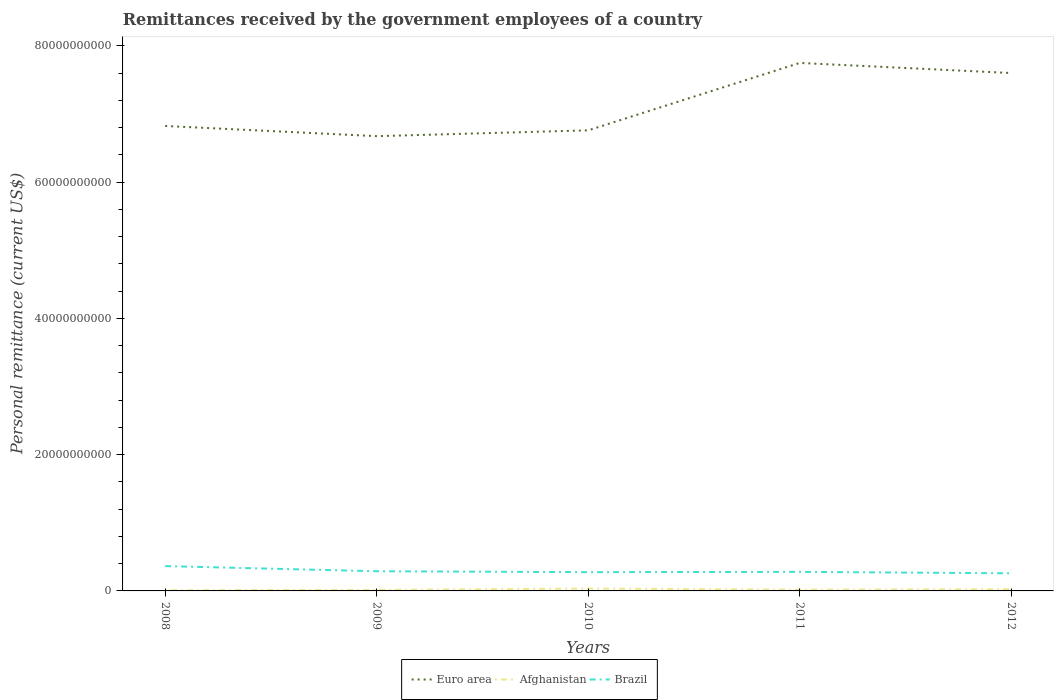How many different coloured lines are there?
Give a very brief answer. 3. Does the line corresponding to Brazil intersect with the line corresponding to Afghanistan?
Provide a short and direct response. No. Is the number of lines equal to the number of legend labels?
Provide a short and direct response. Yes. Across all years, what is the maximum remittances received by the government employees in Euro area?
Your response must be concise. 6.68e+1. In which year was the remittances received by the government employees in Brazil maximum?
Give a very brief answer. 2012. What is the total remittances received by the government employees in Brazil in the graph?
Your answer should be compact. 8.88e+08. What is the difference between the highest and the second highest remittances received by the government employees in Brazil?
Offer a terse response. 1.06e+09. What is the difference between two consecutive major ticks on the Y-axis?
Give a very brief answer. 2.00e+1. Does the graph contain any zero values?
Offer a very short reply. No. Does the graph contain grids?
Your answer should be very brief. No. How many legend labels are there?
Provide a short and direct response. 3. How are the legend labels stacked?
Your answer should be compact. Horizontal. What is the title of the graph?
Offer a very short reply. Remittances received by the government employees of a country. What is the label or title of the Y-axis?
Offer a very short reply. Personal remittance (current US$). What is the Personal remittance (current US$) of Euro area in 2008?
Give a very brief answer. 6.83e+1. What is the Personal remittance (current US$) of Afghanistan in 2008?
Your response must be concise. 1.06e+08. What is the Personal remittance (current US$) in Brazil in 2008?
Keep it short and to the point. 3.64e+09. What is the Personal remittance (current US$) in Euro area in 2009?
Your answer should be very brief. 6.68e+1. What is the Personal remittance (current US$) of Afghanistan in 2009?
Make the answer very short. 1.52e+08. What is the Personal remittance (current US$) in Brazil in 2009?
Offer a terse response. 2.89e+09. What is the Personal remittance (current US$) in Euro area in 2010?
Make the answer very short. 6.76e+1. What is the Personal remittance (current US$) of Afghanistan in 2010?
Make the answer very short. 3.42e+08. What is the Personal remittance (current US$) of Brazil in 2010?
Ensure brevity in your answer.  2.75e+09. What is the Personal remittance (current US$) in Euro area in 2011?
Give a very brief answer. 7.75e+1. What is the Personal remittance (current US$) in Afghanistan in 2011?
Offer a very short reply. 1.85e+08. What is the Personal remittance (current US$) in Brazil in 2011?
Ensure brevity in your answer.  2.80e+09. What is the Personal remittance (current US$) in Euro area in 2012?
Offer a terse response. 7.60e+1. What is the Personal remittance (current US$) of Afghanistan in 2012?
Your response must be concise. 2.52e+08. What is the Personal remittance (current US$) in Brazil in 2012?
Make the answer very short. 2.58e+09. Across all years, what is the maximum Personal remittance (current US$) of Euro area?
Provide a succinct answer. 7.75e+1. Across all years, what is the maximum Personal remittance (current US$) of Afghanistan?
Provide a short and direct response. 3.42e+08. Across all years, what is the maximum Personal remittance (current US$) of Brazil?
Offer a terse response. 3.64e+09. Across all years, what is the minimum Personal remittance (current US$) in Euro area?
Ensure brevity in your answer.  6.68e+1. Across all years, what is the minimum Personal remittance (current US$) of Afghanistan?
Give a very brief answer. 1.06e+08. Across all years, what is the minimum Personal remittance (current US$) of Brazil?
Keep it short and to the point. 2.58e+09. What is the total Personal remittance (current US$) in Euro area in the graph?
Your answer should be very brief. 3.56e+11. What is the total Personal remittance (current US$) in Afghanistan in the graph?
Keep it short and to the point. 1.04e+09. What is the total Personal remittance (current US$) in Brazil in the graph?
Offer a terse response. 1.47e+1. What is the difference between the Personal remittance (current US$) in Euro area in 2008 and that in 2009?
Make the answer very short. 1.50e+09. What is the difference between the Personal remittance (current US$) in Afghanistan in 2008 and that in 2009?
Ensure brevity in your answer.  -4.65e+07. What is the difference between the Personal remittance (current US$) of Brazil in 2008 and that in 2009?
Give a very brief answer. 7.53e+08. What is the difference between the Personal remittance (current US$) of Euro area in 2008 and that in 2010?
Keep it short and to the point. 6.42e+08. What is the difference between the Personal remittance (current US$) in Afghanistan in 2008 and that in 2010?
Offer a terse response. -2.36e+08. What is the difference between the Personal remittance (current US$) in Brazil in 2008 and that in 2010?
Your answer should be compact. 8.88e+08. What is the difference between the Personal remittance (current US$) of Euro area in 2008 and that in 2011?
Give a very brief answer. -9.25e+09. What is the difference between the Personal remittance (current US$) of Afghanistan in 2008 and that in 2011?
Your answer should be compact. -7.97e+07. What is the difference between the Personal remittance (current US$) in Brazil in 2008 and that in 2011?
Ensure brevity in your answer.  8.44e+08. What is the difference between the Personal remittance (current US$) of Euro area in 2008 and that in 2012?
Provide a succinct answer. -7.77e+09. What is the difference between the Personal remittance (current US$) of Afghanistan in 2008 and that in 2012?
Your answer should be very brief. -1.46e+08. What is the difference between the Personal remittance (current US$) of Brazil in 2008 and that in 2012?
Your answer should be very brief. 1.06e+09. What is the difference between the Personal remittance (current US$) in Euro area in 2009 and that in 2010?
Give a very brief answer. -8.54e+08. What is the difference between the Personal remittance (current US$) in Afghanistan in 2009 and that in 2010?
Provide a short and direct response. -1.90e+08. What is the difference between the Personal remittance (current US$) in Brazil in 2009 and that in 2010?
Keep it short and to the point. 1.35e+08. What is the difference between the Personal remittance (current US$) in Euro area in 2009 and that in 2011?
Offer a very short reply. -1.07e+1. What is the difference between the Personal remittance (current US$) in Afghanistan in 2009 and that in 2011?
Your answer should be compact. -3.31e+07. What is the difference between the Personal remittance (current US$) of Brazil in 2009 and that in 2011?
Provide a succinct answer. 9.07e+07. What is the difference between the Personal remittance (current US$) of Euro area in 2009 and that in 2012?
Your answer should be compact. -9.27e+09. What is the difference between the Personal remittance (current US$) of Afghanistan in 2009 and that in 2012?
Your response must be concise. -9.95e+07. What is the difference between the Personal remittance (current US$) of Brazil in 2009 and that in 2012?
Make the answer very short. 3.07e+08. What is the difference between the Personal remittance (current US$) of Euro area in 2010 and that in 2011?
Make the answer very short. -9.90e+09. What is the difference between the Personal remittance (current US$) in Afghanistan in 2010 and that in 2011?
Provide a succinct answer. 1.57e+08. What is the difference between the Personal remittance (current US$) of Brazil in 2010 and that in 2011?
Offer a very short reply. -4.43e+07. What is the difference between the Personal remittance (current US$) of Euro area in 2010 and that in 2012?
Keep it short and to the point. -8.41e+09. What is the difference between the Personal remittance (current US$) in Afghanistan in 2010 and that in 2012?
Offer a very short reply. 9.03e+07. What is the difference between the Personal remittance (current US$) of Brazil in 2010 and that in 2012?
Keep it short and to the point. 1.71e+08. What is the difference between the Personal remittance (current US$) of Euro area in 2011 and that in 2012?
Offer a very short reply. 1.48e+09. What is the difference between the Personal remittance (current US$) in Afghanistan in 2011 and that in 2012?
Ensure brevity in your answer.  -6.64e+07. What is the difference between the Personal remittance (current US$) in Brazil in 2011 and that in 2012?
Offer a terse response. 2.16e+08. What is the difference between the Personal remittance (current US$) of Euro area in 2008 and the Personal remittance (current US$) of Afghanistan in 2009?
Ensure brevity in your answer.  6.81e+1. What is the difference between the Personal remittance (current US$) in Euro area in 2008 and the Personal remittance (current US$) in Brazil in 2009?
Offer a very short reply. 6.54e+1. What is the difference between the Personal remittance (current US$) in Afghanistan in 2008 and the Personal remittance (current US$) in Brazil in 2009?
Provide a succinct answer. -2.78e+09. What is the difference between the Personal remittance (current US$) in Euro area in 2008 and the Personal remittance (current US$) in Afghanistan in 2010?
Make the answer very short. 6.79e+1. What is the difference between the Personal remittance (current US$) of Euro area in 2008 and the Personal remittance (current US$) of Brazil in 2010?
Provide a succinct answer. 6.55e+1. What is the difference between the Personal remittance (current US$) of Afghanistan in 2008 and the Personal remittance (current US$) of Brazil in 2010?
Your answer should be compact. -2.65e+09. What is the difference between the Personal remittance (current US$) of Euro area in 2008 and the Personal remittance (current US$) of Afghanistan in 2011?
Make the answer very short. 6.81e+1. What is the difference between the Personal remittance (current US$) of Euro area in 2008 and the Personal remittance (current US$) of Brazil in 2011?
Your response must be concise. 6.55e+1. What is the difference between the Personal remittance (current US$) of Afghanistan in 2008 and the Personal remittance (current US$) of Brazil in 2011?
Your answer should be very brief. -2.69e+09. What is the difference between the Personal remittance (current US$) of Euro area in 2008 and the Personal remittance (current US$) of Afghanistan in 2012?
Offer a very short reply. 6.80e+1. What is the difference between the Personal remittance (current US$) of Euro area in 2008 and the Personal remittance (current US$) of Brazil in 2012?
Ensure brevity in your answer.  6.57e+1. What is the difference between the Personal remittance (current US$) of Afghanistan in 2008 and the Personal remittance (current US$) of Brazil in 2012?
Provide a succinct answer. -2.48e+09. What is the difference between the Personal remittance (current US$) of Euro area in 2009 and the Personal remittance (current US$) of Afghanistan in 2010?
Your response must be concise. 6.64e+1. What is the difference between the Personal remittance (current US$) in Euro area in 2009 and the Personal remittance (current US$) in Brazil in 2010?
Your response must be concise. 6.40e+1. What is the difference between the Personal remittance (current US$) of Afghanistan in 2009 and the Personal remittance (current US$) of Brazil in 2010?
Offer a terse response. -2.60e+09. What is the difference between the Personal remittance (current US$) of Euro area in 2009 and the Personal remittance (current US$) of Afghanistan in 2011?
Provide a short and direct response. 6.66e+1. What is the difference between the Personal remittance (current US$) in Euro area in 2009 and the Personal remittance (current US$) in Brazil in 2011?
Keep it short and to the point. 6.40e+1. What is the difference between the Personal remittance (current US$) in Afghanistan in 2009 and the Personal remittance (current US$) in Brazil in 2011?
Your answer should be very brief. -2.65e+09. What is the difference between the Personal remittance (current US$) in Euro area in 2009 and the Personal remittance (current US$) in Afghanistan in 2012?
Keep it short and to the point. 6.65e+1. What is the difference between the Personal remittance (current US$) of Euro area in 2009 and the Personal remittance (current US$) of Brazil in 2012?
Provide a short and direct response. 6.42e+1. What is the difference between the Personal remittance (current US$) in Afghanistan in 2009 and the Personal remittance (current US$) in Brazil in 2012?
Give a very brief answer. -2.43e+09. What is the difference between the Personal remittance (current US$) in Euro area in 2010 and the Personal remittance (current US$) in Afghanistan in 2011?
Offer a terse response. 6.74e+1. What is the difference between the Personal remittance (current US$) in Euro area in 2010 and the Personal remittance (current US$) in Brazil in 2011?
Ensure brevity in your answer.  6.48e+1. What is the difference between the Personal remittance (current US$) in Afghanistan in 2010 and the Personal remittance (current US$) in Brazil in 2011?
Ensure brevity in your answer.  -2.46e+09. What is the difference between the Personal remittance (current US$) of Euro area in 2010 and the Personal remittance (current US$) of Afghanistan in 2012?
Make the answer very short. 6.74e+1. What is the difference between the Personal remittance (current US$) of Euro area in 2010 and the Personal remittance (current US$) of Brazil in 2012?
Offer a very short reply. 6.50e+1. What is the difference between the Personal remittance (current US$) of Afghanistan in 2010 and the Personal remittance (current US$) of Brazil in 2012?
Your answer should be very brief. -2.24e+09. What is the difference between the Personal remittance (current US$) in Euro area in 2011 and the Personal remittance (current US$) in Afghanistan in 2012?
Offer a terse response. 7.73e+1. What is the difference between the Personal remittance (current US$) of Euro area in 2011 and the Personal remittance (current US$) of Brazil in 2012?
Offer a very short reply. 7.49e+1. What is the difference between the Personal remittance (current US$) of Afghanistan in 2011 and the Personal remittance (current US$) of Brazil in 2012?
Offer a very short reply. -2.40e+09. What is the average Personal remittance (current US$) in Euro area per year?
Keep it short and to the point. 7.12e+1. What is the average Personal remittance (current US$) in Afghanistan per year?
Provide a short and direct response. 2.07e+08. What is the average Personal remittance (current US$) in Brazil per year?
Ensure brevity in your answer.  2.93e+09. In the year 2008, what is the difference between the Personal remittance (current US$) in Euro area and Personal remittance (current US$) in Afghanistan?
Keep it short and to the point. 6.81e+1. In the year 2008, what is the difference between the Personal remittance (current US$) in Euro area and Personal remittance (current US$) in Brazil?
Your answer should be compact. 6.46e+1. In the year 2008, what is the difference between the Personal remittance (current US$) in Afghanistan and Personal remittance (current US$) in Brazil?
Offer a terse response. -3.54e+09. In the year 2009, what is the difference between the Personal remittance (current US$) of Euro area and Personal remittance (current US$) of Afghanistan?
Your answer should be very brief. 6.66e+1. In the year 2009, what is the difference between the Personal remittance (current US$) in Euro area and Personal remittance (current US$) in Brazil?
Make the answer very short. 6.39e+1. In the year 2009, what is the difference between the Personal remittance (current US$) of Afghanistan and Personal remittance (current US$) of Brazil?
Provide a succinct answer. -2.74e+09. In the year 2010, what is the difference between the Personal remittance (current US$) of Euro area and Personal remittance (current US$) of Afghanistan?
Make the answer very short. 6.73e+1. In the year 2010, what is the difference between the Personal remittance (current US$) of Euro area and Personal remittance (current US$) of Brazil?
Offer a terse response. 6.49e+1. In the year 2010, what is the difference between the Personal remittance (current US$) of Afghanistan and Personal remittance (current US$) of Brazil?
Give a very brief answer. -2.41e+09. In the year 2011, what is the difference between the Personal remittance (current US$) in Euro area and Personal remittance (current US$) in Afghanistan?
Your answer should be compact. 7.73e+1. In the year 2011, what is the difference between the Personal remittance (current US$) in Euro area and Personal remittance (current US$) in Brazil?
Make the answer very short. 7.47e+1. In the year 2011, what is the difference between the Personal remittance (current US$) of Afghanistan and Personal remittance (current US$) of Brazil?
Your response must be concise. -2.61e+09. In the year 2012, what is the difference between the Personal remittance (current US$) of Euro area and Personal remittance (current US$) of Afghanistan?
Your response must be concise. 7.58e+1. In the year 2012, what is the difference between the Personal remittance (current US$) of Euro area and Personal remittance (current US$) of Brazil?
Make the answer very short. 7.34e+1. In the year 2012, what is the difference between the Personal remittance (current US$) of Afghanistan and Personal remittance (current US$) of Brazil?
Your response must be concise. -2.33e+09. What is the ratio of the Personal remittance (current US$) of Euro area in 2008 to that in 2009?
Your response must be concise. 1.02. What is the ratio of the Personal remittance (current US$) of Afghanistan in 2008 to that in 2009?
Ensure brevity in your answer.  0.69. What is the ratio of the Personal remittance (current US$) in Brazil in 2008 to that in 2009?
Make the answer very short. 1.26. What is the ratio of the Personal remittance (current US$) of Euro area in 2008 to that in 2010?
Make the answer very short. 1.01. What is the ratio of the Personal remittance (current US$) of Afghanistan in 2008 to that in 2010?
Offer a very short reply. 0.31. What is the ratio of the Personal remittance (current US$) of Brazil in 2008 to that in 2010?
Keep it short and to the point. 1.32. What is the ratio of the Personal remittance (current US$) in Euro area in 2008 to that in 2011?
Ensure brevity in your answer.  0.88. What is the ratio of the Personal remittance (current US$) in Afghanistan in 2008 to that in 2011?
Your response must be concise. 0.57. What is the ratio of the Personal remittance (current US$) of Brazil in 2008 to that in 2011?
Keep it short and to the point. 1.3. What is the ratio of the Personal remittance (current US$) in Euro area in 2008 to that in 2012?
Keep it short and to the point. 0.9. What is the ratio of the Personal remittance (current US$) in Afghanistan in 2008 to that in 2012?
Your answer should be very brief. 0.42. What is the ratio of the Personal remittance (current US$) in Brazil in 2008 to that in 2012?
Your response must be concise. 1.41. What is the ratio of the Personal remittance (current US$) in Euro area in 2009 to that in 2010?
Ensure brevity in your answer.  0.99. What is the ratio of the Personal remittance (current US$) in Afghanistan in 2009 to that in 2010?
Provide a short and direct response. 0.45. What is the ratio of the Personal remittance (current US$) of Brazil in 2009 to that in 2010?
Keep it short and to the point. 1.05. What is the ratio of the Personal remittance (current US$) of Euro area in 2009 to that in 2011?
Your answer should be very brief. 0.86. What is the ratio of the Personal remittance (current US$) of Afghanistan in 2009 to that in 2011?
Provide a short and direct response. 0.82. What is the ratio of the Personal remittance (current US$) of Brazil in 2009 to that in 2011?
Your response must be concise. 1.03. What is the ratio of the Personal remittance (current US$) of Euro area in 2009 to that in 2012?
Offer a very short reply. 0.88. What is the ratio of the Personal remittance (current US$) in Afghanistan in 2009 to that in 2012?
Offer a terse response. 0.6. What is the ratio of the Personal remittance (current US$) of Brazil in 2009 to that in 2012?
Make the answer very short. 1.12. What is the ratio of the Personal remittance (current US$) in Euro area in 2010 to that in 2011?
Your response must be concise. 0.87. What is the ratio of the Personal remittance (current US$) of Afghanistan in 2010 to that in 2011?
Offer a terse response. 1.85. What is the ratio of the Personal remittance (current US$) in Brazil in 2010 to that in 2011?
Give a very brief answer. 0.98. What is the ratio of the Personal remittance (current US$) in Euro area in 2010 to that in 2012?
Keep it short and to the point. 0.89. What is the ratio of the Personal remittance (current US$) of Afghanistan in 2010 to that in 2012?
Offer a terse response. 1.36. What is the ratio of the Personal remittance (current US$) of Brazil in 2010 to that in 2012?
Give a very brief answer. 1.07. What is the ratio of the Personal remittance (current US$) of Euro area in 2011 to that in 2012?
Offer a terse response. 1.02. What is the ratio of the Personal remittance (current US$) in Afghanistan in 2011 to that in 2012?
Offer a terse response. 0.74. What is the ratio of the Personal remittance (current US$) in Brazil in 2011 to that in 2012?
Offer a terse response. 1.08. What is the difference between the highest and the second highest Personal remittance (current US$) of Euro area?
Your answer should be compact. 1.48e+09. What is the difference between the highest and the second highest Personal remittance (current US$) of Afghanistan?
Offer a very short reply. 9.03e+07. What is the difference between the highest and the second highest Personal remittance (current US$) of Brazil?
Offer a terse response. 7.53e+08. What is the difference between the highest and the lowest Personal remittance (current US$) in Euro area?
Provide a short and direct response. 1.07e+1. What is the difference between the highest and the lowest Personal remittance (current US$) in Afghanistan?
Give a very brief answer. 2.36e+08. What is the difference between the highest and the lowest Personal remittance (current US$) in Brazil?
Provide a short and direct response. 1.06e+09. 